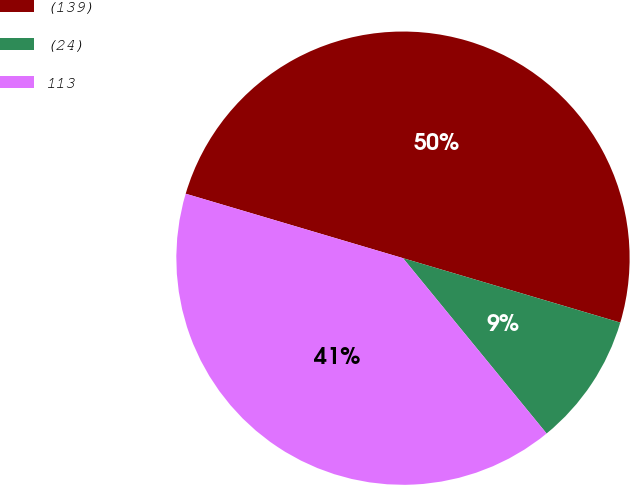<chart> <loc_0><loc_0><loc_500><loc_500><pie_chart><fcel>(139)<fcel>(24)<fcel>113<nl><fcel>50.0%<fcel>9.49%<fcel>40.51%<nl></chart> 